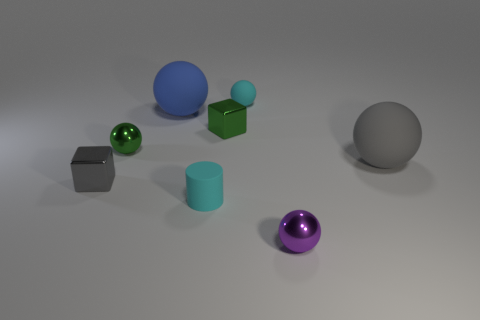Subtract all matte balls. How many balls are left? 2 Add 1 purple shiny objects. How many objects exist? 9 Subtract all gray spheres. How many spheres are left? 4 Subtract 3 spheres. How many spheres are left? 2 Add 7 cyan matte cylinders. How many cyan matte cylinders are left? 8 Add 7 gray rubber spheres. How many gray rubber spheres exist? 8 Subtract 0 blue blocks. How many objects are left? 8 Subtract all cubes. How many objects are left? 6 Subtract all brown cylinders. Subtract all gray blocks. How many cylinders are left? 1 Subtract all green blocks. How many red spheres are left? 0 